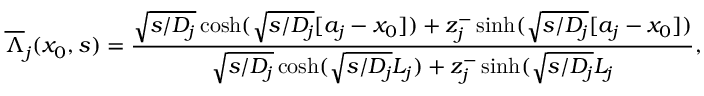<formula> <loc_0><loc_0><loc_500><loc_500>\overline { \Lambda } _ { j } ( x _ { 0 } , s ) = \frac { \sqrt { s / D _ { j } } \cosh ( \sqrt { s / D _ { j } } [ a _ { j } - x _ { 0 } ] ) + z _ { j } ^ { - } \sinh ( \sqrt { s / D _ { j } } [ a _ { j } - x _ { 0 } ] ) } { \sqrt { s / D _ { j } } \cosh ( \sqrt { s / D _ { j } } L _ { j } ) + z _ { j } ^ { - } \sinh ( \sqrt { s / D _ { j } } L _ { j } } ,</formula> 